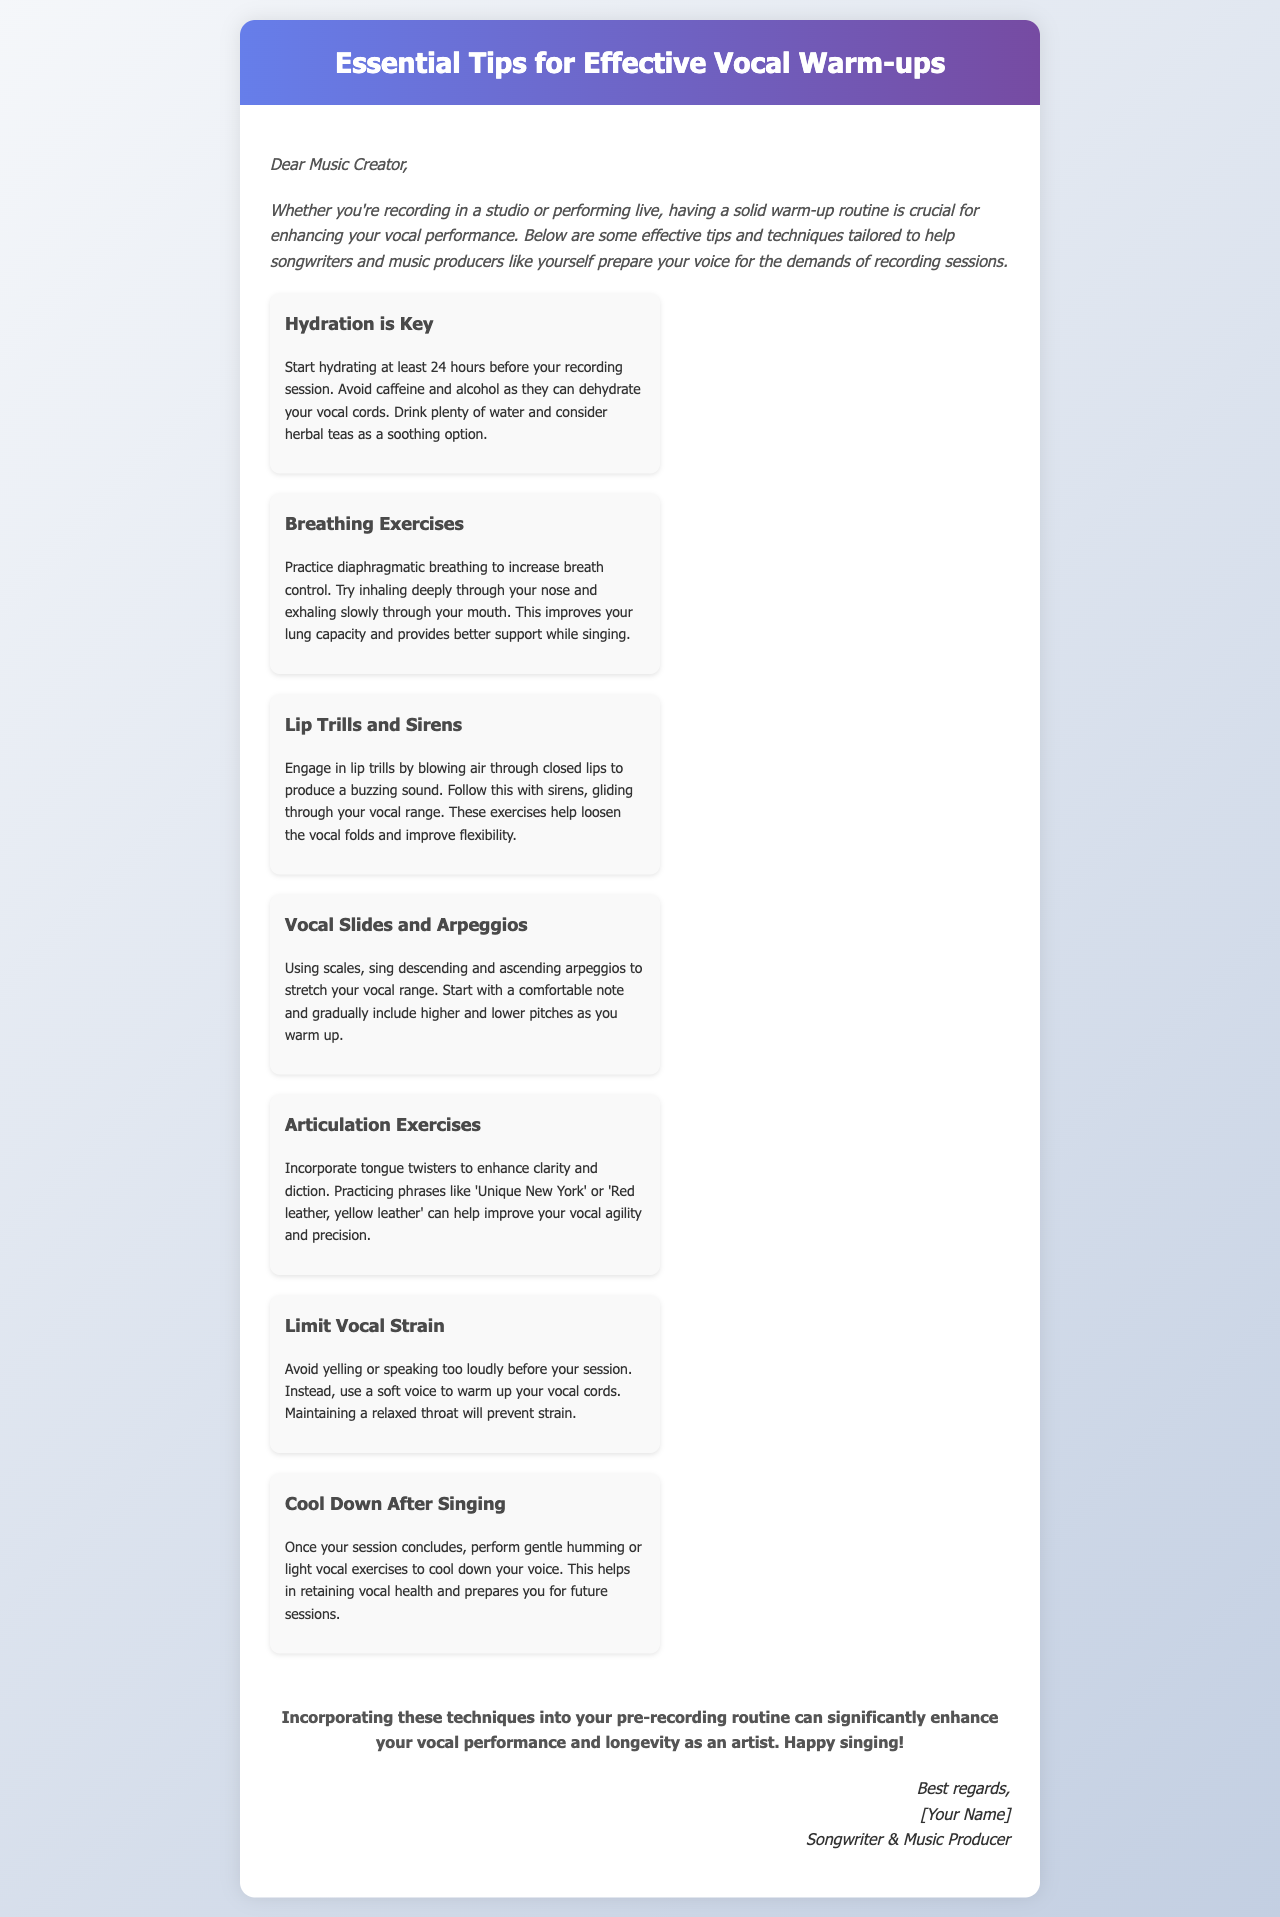What is the title of the document? The title is presented in the header section of the document.
Answer: Essential Tips for Effective Vocal Warm-ups Who is the intended audience of this document? The introduction specifies who the tips are tailored for.
Answer: Music Creator What is emphasized as important for vocal health before a recording session? The document highlights key practices that enhance vocal performance, particularly at the beginning.
Answer: Hydration Which exercise helps improve breath control according to the document? Breathing exercises are specifically mentioned to enhance vocal performance.
Answer: Diaphragmatic breathing What should singers avoid to prevent dehydration? The document lists substances that are detrimental to hydration and vocal health.
Answer: Caffeine and alcohol What type of exercise helps with vocal flexibility? Certain vocal techniques mentioned improve flexibility in performance.
Answer: Lip trills and sirens What are tongue twisters used for in vocal warm-ups? The purpose of articulation exercises is clarified in the document.
Answer: Enhance clarity and diction How should one cool down after singing? The document provides guidance on post-singing care to maintain vocal health.
Answer: Gentle humming or light vocal exercises 